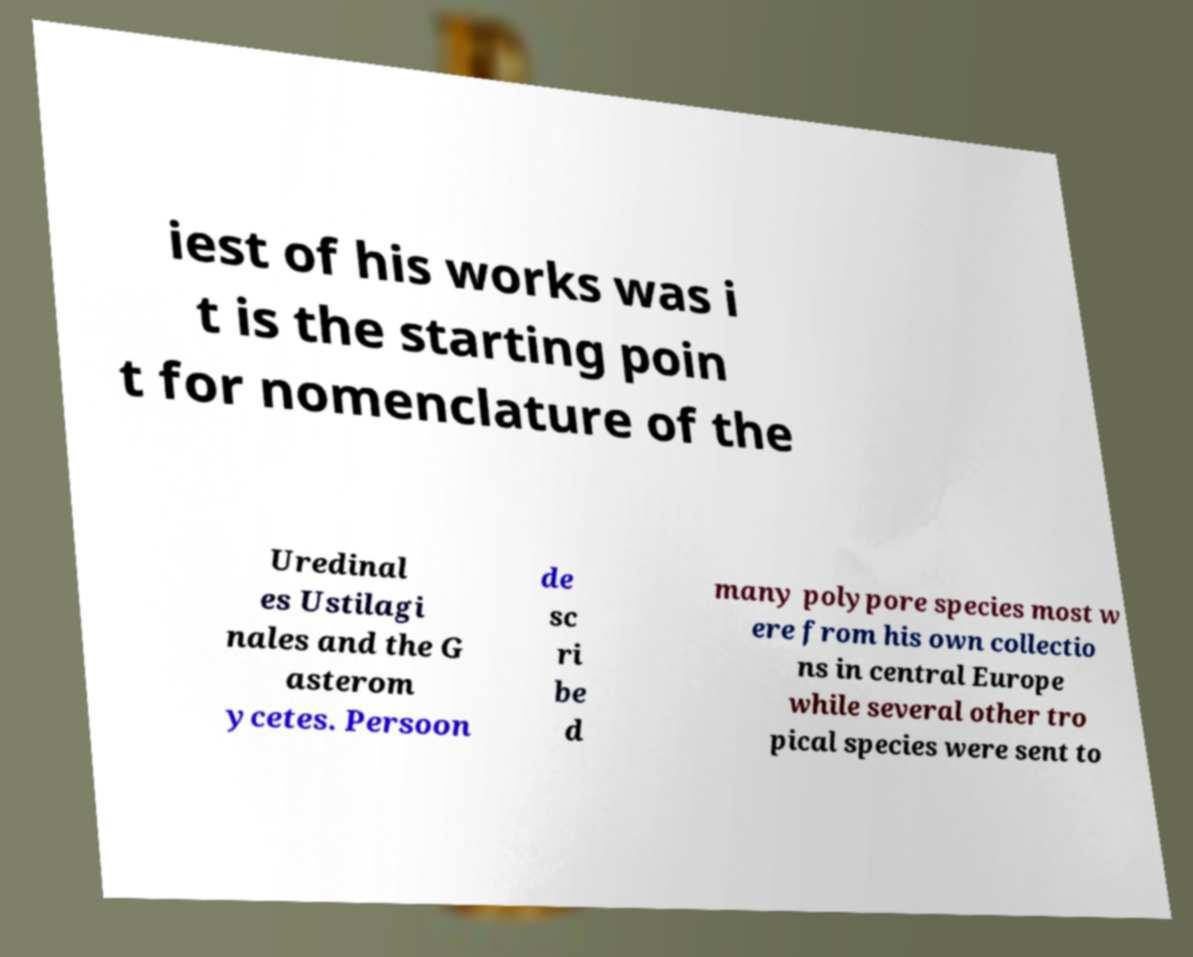For documentation purposes, I need the text within this image transcribed. Could you provide that? iest of his works was i t is the starting poin t for nomenclature of the Uredinal es Ustilagi nales and the G asterom ycetes. Persoon de sc ri be d many polypore species most w ere from his own collectio ns in central Europe while several other tro pical species were sent to 